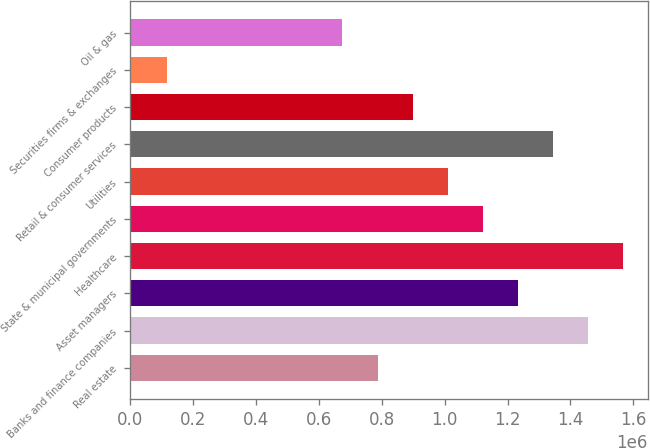<chart> <loc_0><loc_0><loc_500><loc_500><bar_chart><fcel>Real estate<fcel>Banks and finance companies<fcel>Asset managers<fcel>Healthcare<fcel>State & municipal governments<fcel>Utilities<fcel>Retail & consumer services<fcel>Consumer products<fcel>Securities firms & exchanges<fcel>Oil & gas<nl><fcel>786215<fcel>1.45654e+06<fcel>1.2331e+06<fcel>1.56826e+06<fcel>1.12138e+06<fcel>1.00966e+06<fcel>1.34482e+06<fcel>897936<fcel>115888<fcel>674494<nl></chart> 